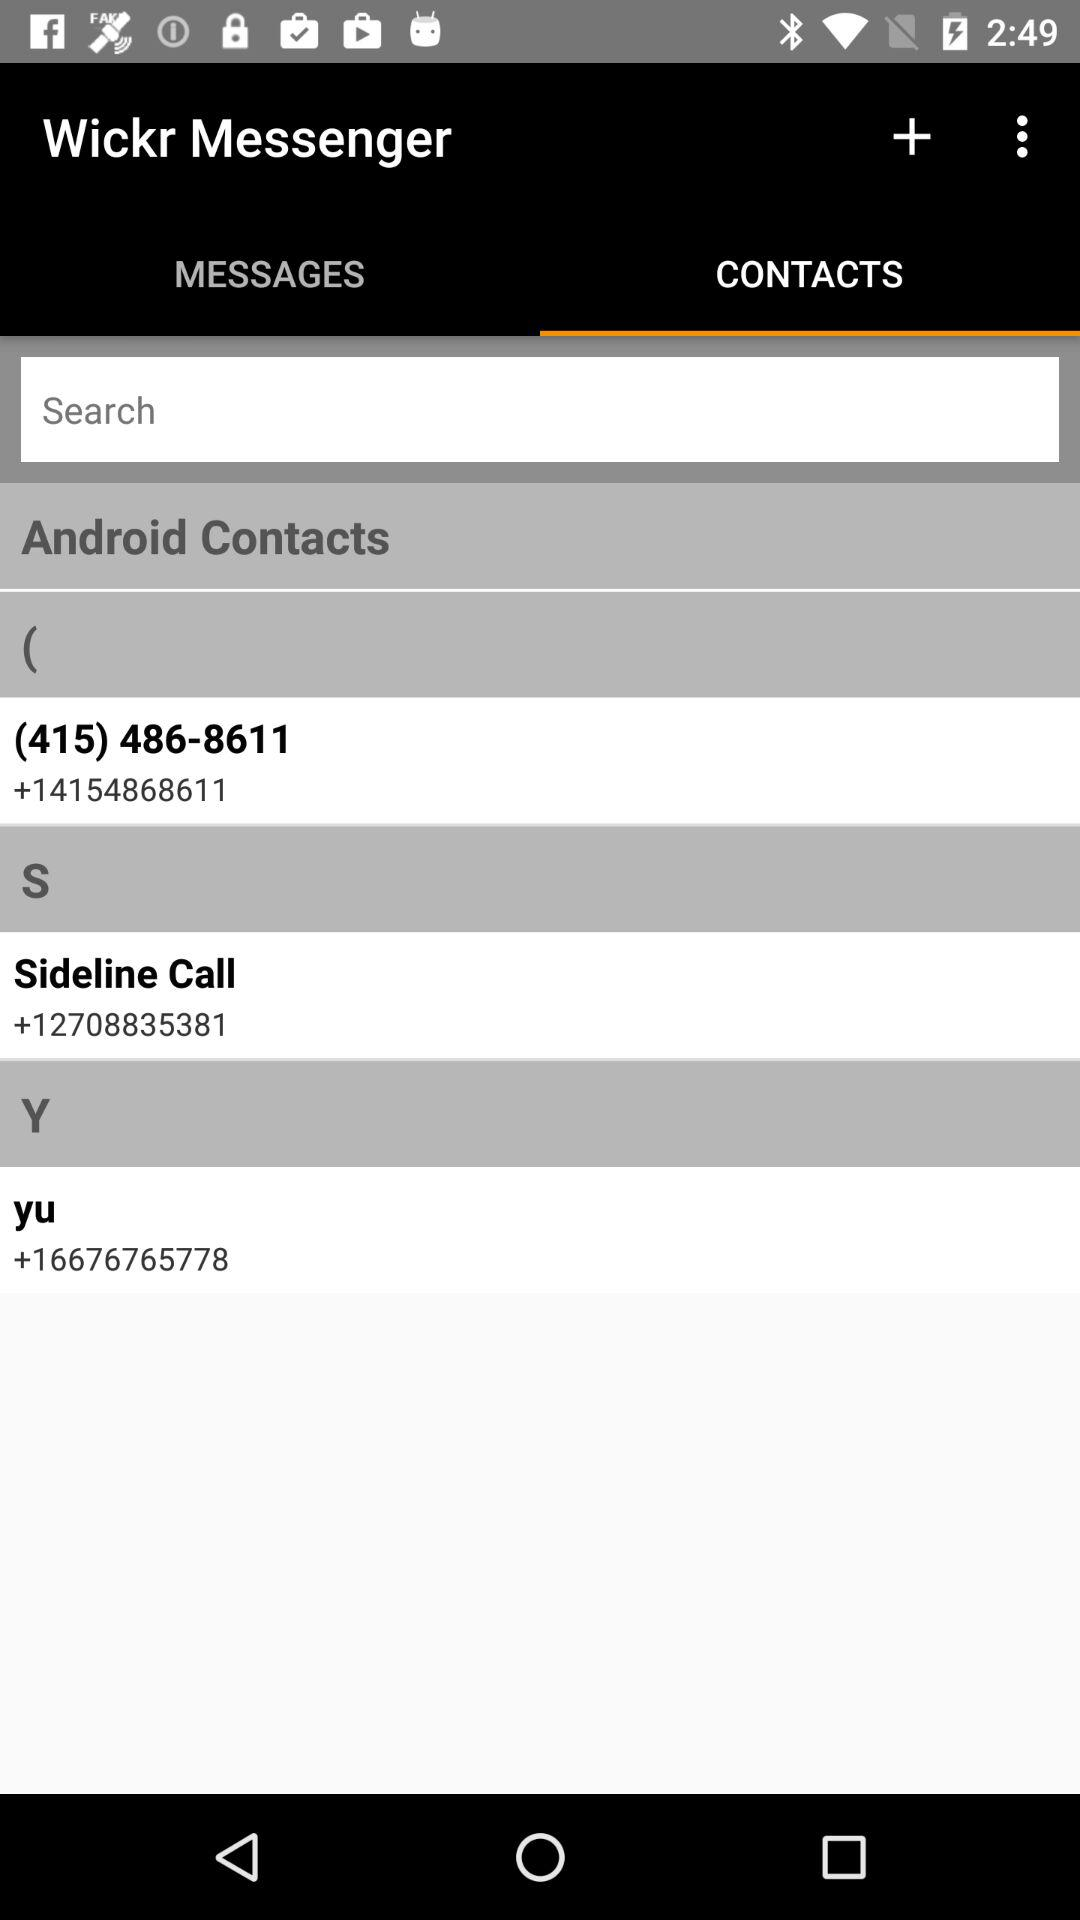Which tab is selected? The selected tab is "CONTACTS". 